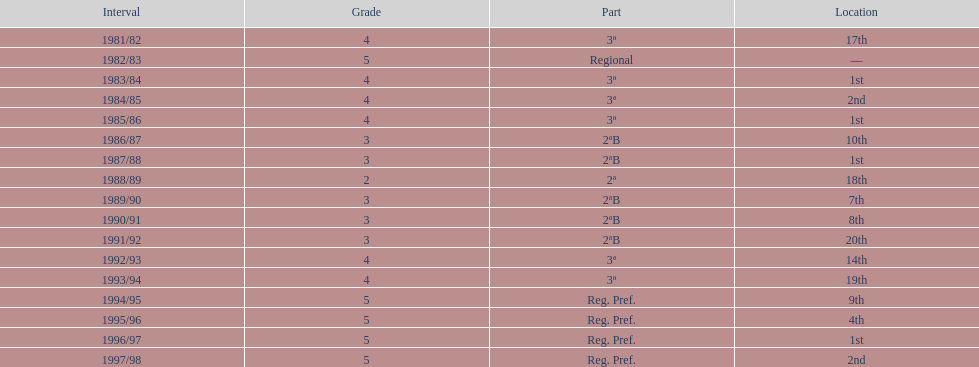In which rank was ud alzira a member the least? 2. 